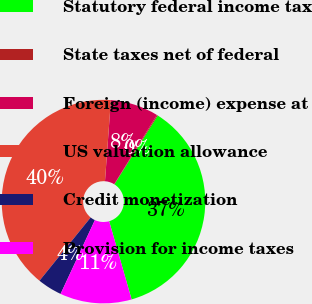<chart> <loc_0><loc_0><loc_500><loc_500><pie_chart><fcel>Statutory federal income tax<fcel>State taxes net of federal<fcel>Foreign (income) expense at<fcel>US valuation allowance<fcel>Credit monetization<fcel>Provision for income taxes<nl><fcel>36.59%<fcel>0.16%<fcel>7.64%<fcel>40.33%<fcel>3.9%<fcel>11.38%<nl></chart> 